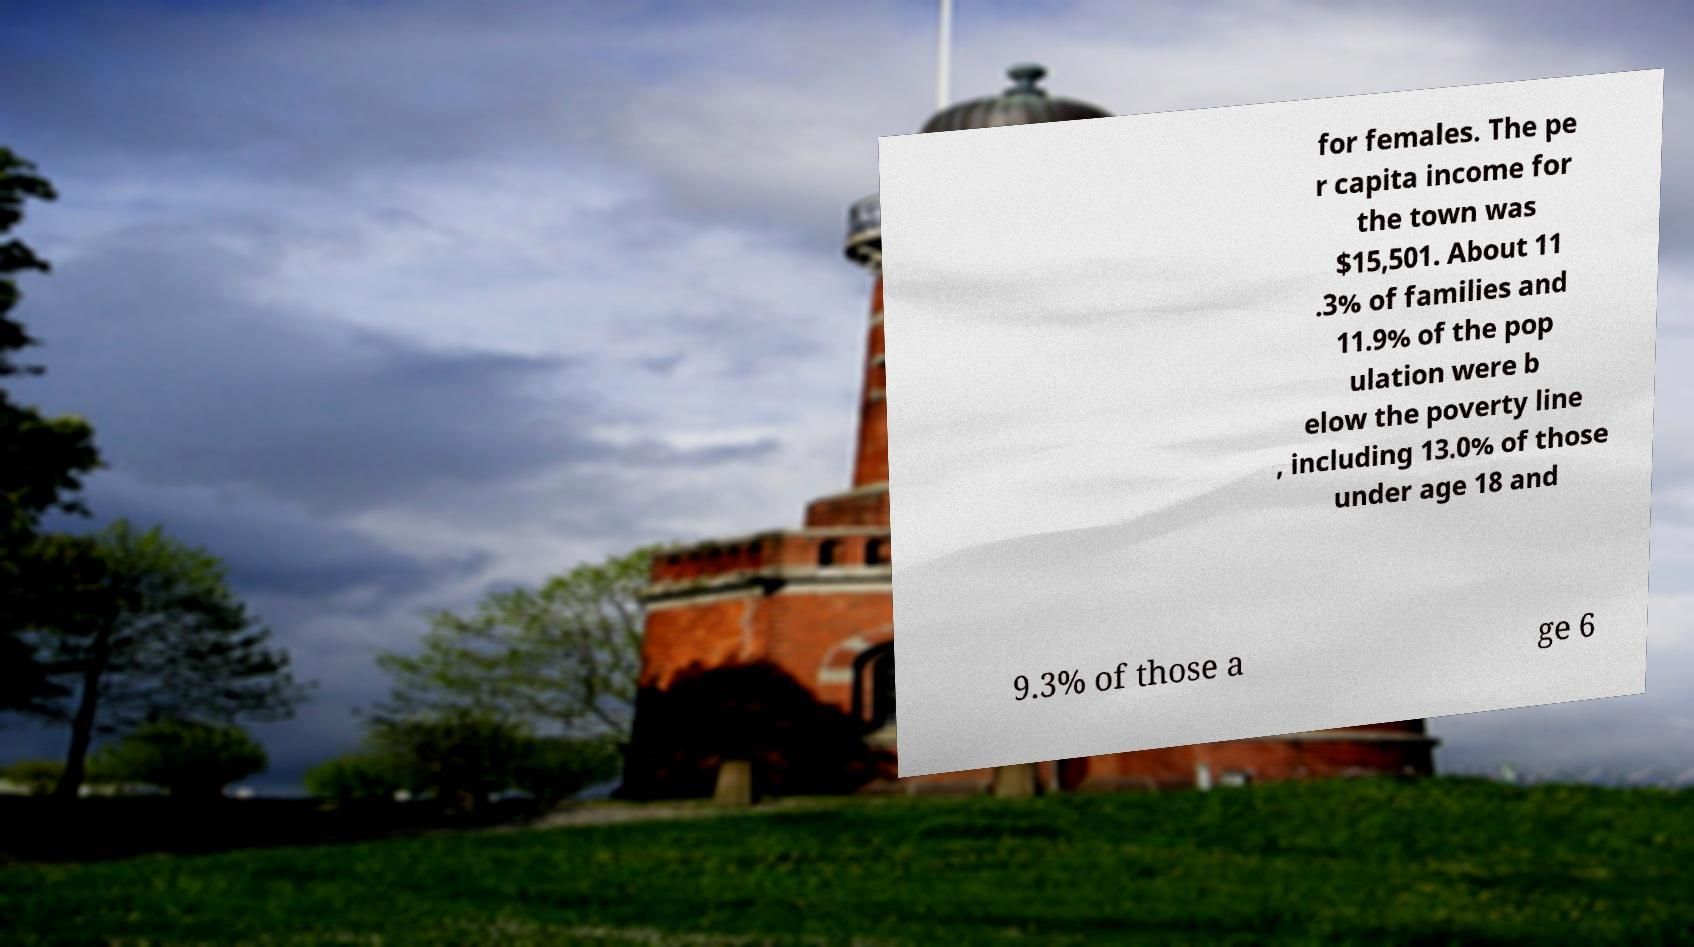Can you read and provide the text displayed in the image?This photo seems to have some interesting text. Can you extract and type it out for me? for females. The pe r capita income for the town was $15,501. About 11 .3% of families and 11.9% of the pop ulation were b elow the poverty line , including 13.0% of those under age 18 and 9.3% of those a ge 6 